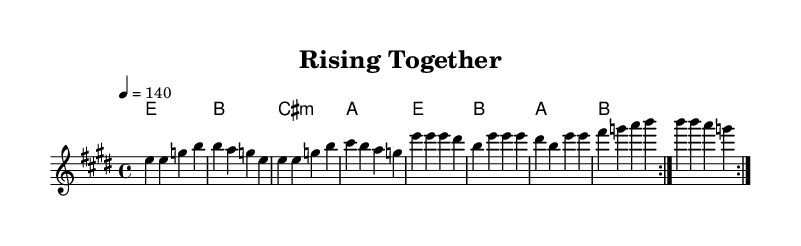What is the key signature of this music? The key signature is indicated by the sharp symbols at the beginning of the staff. In this case, there are four sharps, which means the key is E major.
Answer: E major What is the time signature of this music? The time signature can be found at the beginning of the staff next to the key signature. Here, it is shown as 4/4, which means there are four beats in each measure and the quarter note gets one beat.
Answer: 4/4 What is the tempo marking for this piece? The tempo marking is indicated in the score, showing how fast the piece should be played. In this case, it states "4 = 140," indicating the metronome marking of 140 beats per minute.
Answer: 140 How many measures are in each repeated section? The repeated sections are indicated by the volta markings. Observing the melody, we can see each repeat contains four measures, and since it repeats two times, we can conclude there are four measures in each repeated section.
Answer: 4 What musical elements are celebrated in the lyrics? The lyrics focus on themes of community support and overcoming challenges, aligning with the purpose of rehabilitation and emotional strength. The words explicitly indicate these themes through phrases associated with growth and support.
Answer: Community support What genre is this piece classified under? The stylistic elements, including the energetic tempo and rock harmonies, along with the emotional themes of support and rehabilitation, classify this piece within the rock genre.
Answer: Rock What is the function of the harmonies in this piece? The harmonies provide the underlying chord structure that supports the melody. In this score, the chord progressions are structured to create a sense of movement and resolution, typical in rock music, emphasizing the uplifting nature of the lyrics.
Answer: Support the melody 